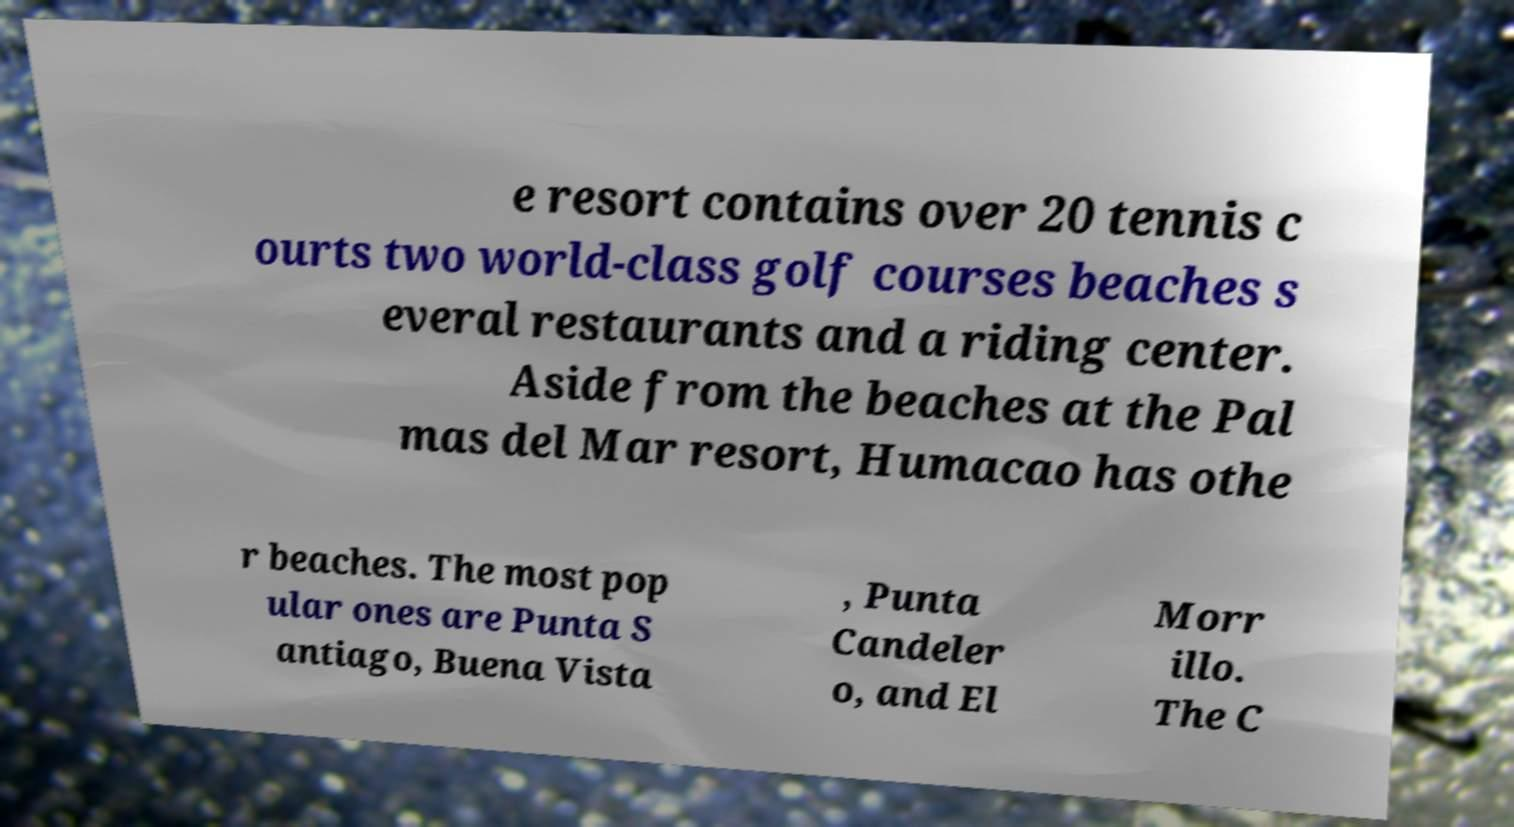Could you assist in decoding the text presented in this image and type it out clearly? e resort contains over 20 tennis c ourts two world-class golf courses beaches s everal restaurants and a riding center. Aside from the beaches at the Pal mas del Mar resort, Humacao has othe r beaches. The most pop ular ones are Punta S antiago, Buena Vista , Punta Candeler o, and El Morr illo. The C 